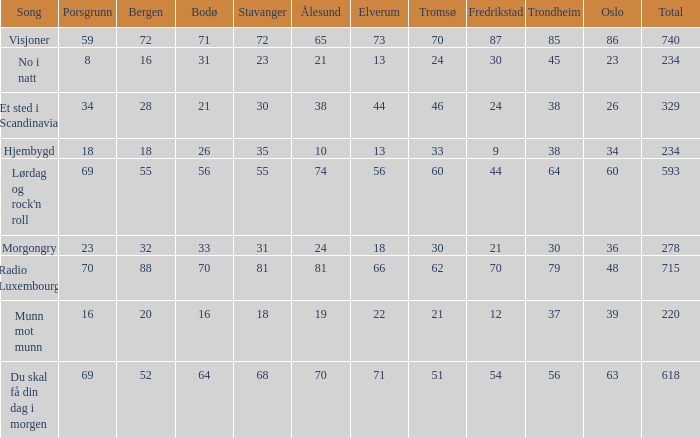What was the total for radio luxembourg? 715.0. 